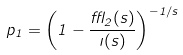Convert formula to latex. <formula><loc_0><loc_0><loc_500><loc_500>p _ { 1 } = \left ( 1 - \frac { \epsilon _ { 2 } ( s ) } { \zeta ( s ) } \right ) ^ { - 1 / s }</formula> 